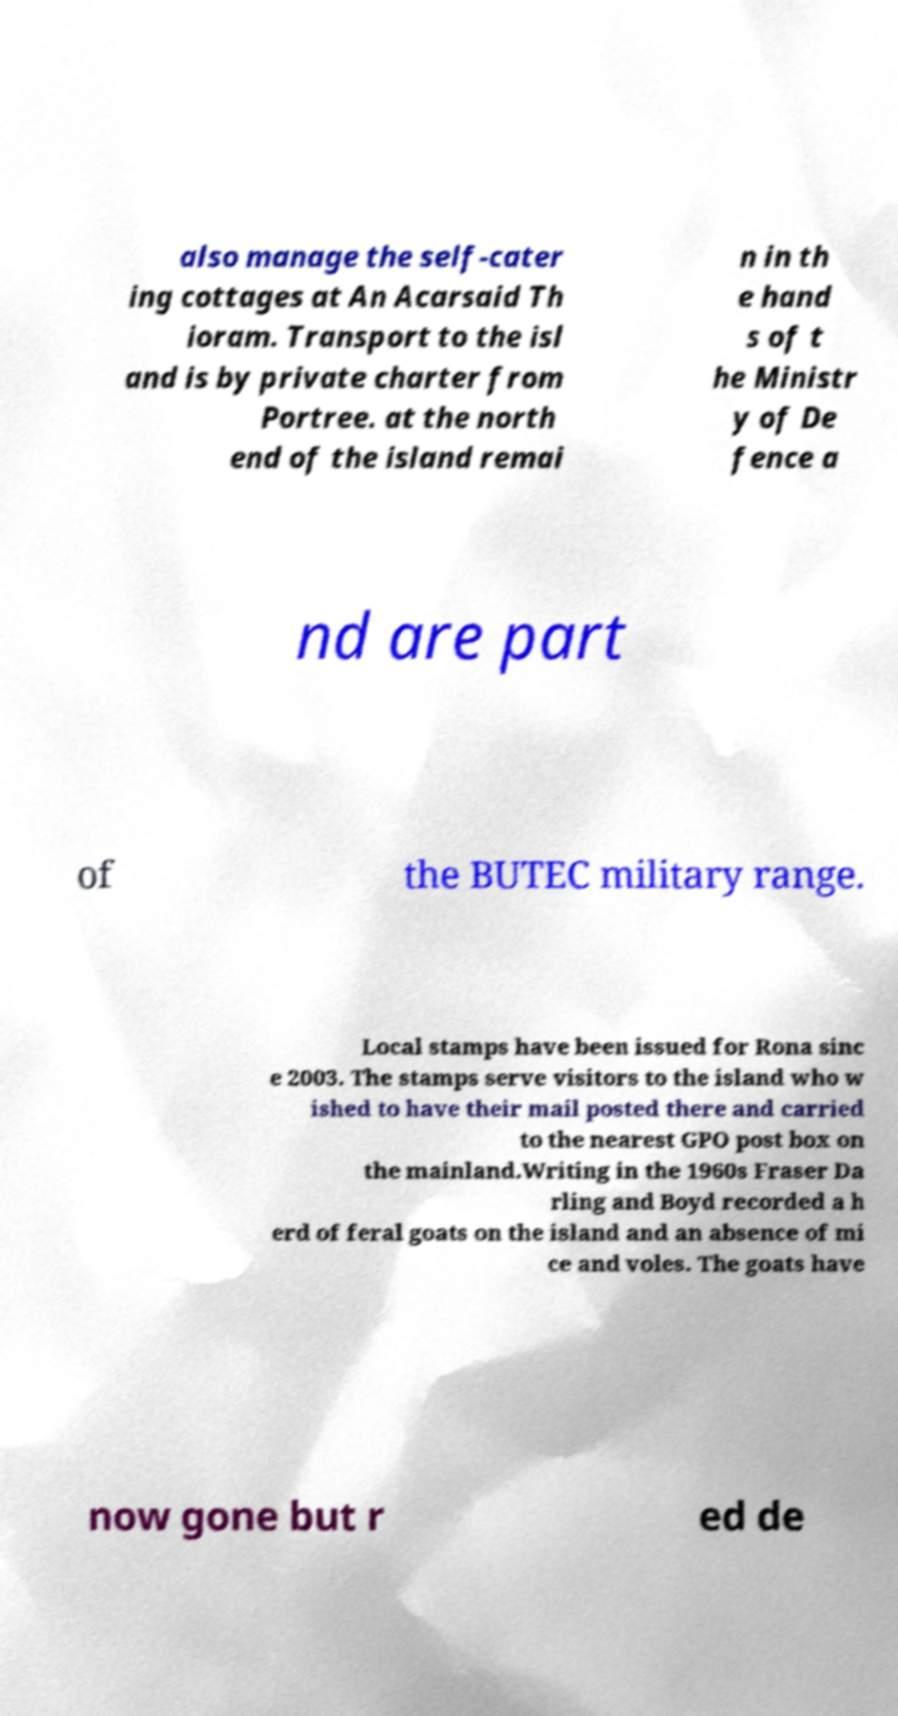Please read and relay the text visible in this image. What does it say? also manage the self-cater ing cottages at An Acarsaid Th ioram. Transport to the isl and is by private charter from Portree. at the north end of the island remai n in th e hand s of t he Ministr y of De fence a nd are part of the BUTEC military range. Local stamps have been issued for Rona sinc e 2003. The stamps serve visitors to the island who w ished to have their mail posted there and carried to the nearest GPO post box on the mainland.Writing in the 1960s Fraser Da rling and Boyd recorded a h erd of feral goats on the island and an absence of mi ce and voles. The goats have now gone but r ed de 